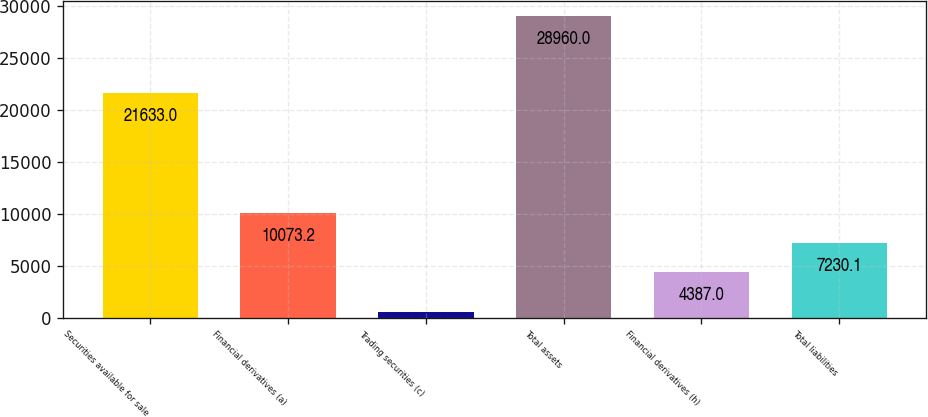<chart> <loc_0><loc_0><loc_500><loc_500><bar_chart><fcel>Securities available for sale<fcel>Financial derivatives (a)<fcel>Trading securities (c)<fcel>Total assets<fcel>Financial derivatives (h)<fcel>Total liabilities<nl><fcel>21633<fcel>10073.2<fcel>529<fcel>28960<fcel>4387<fcel>7230.1<nl></chart> 